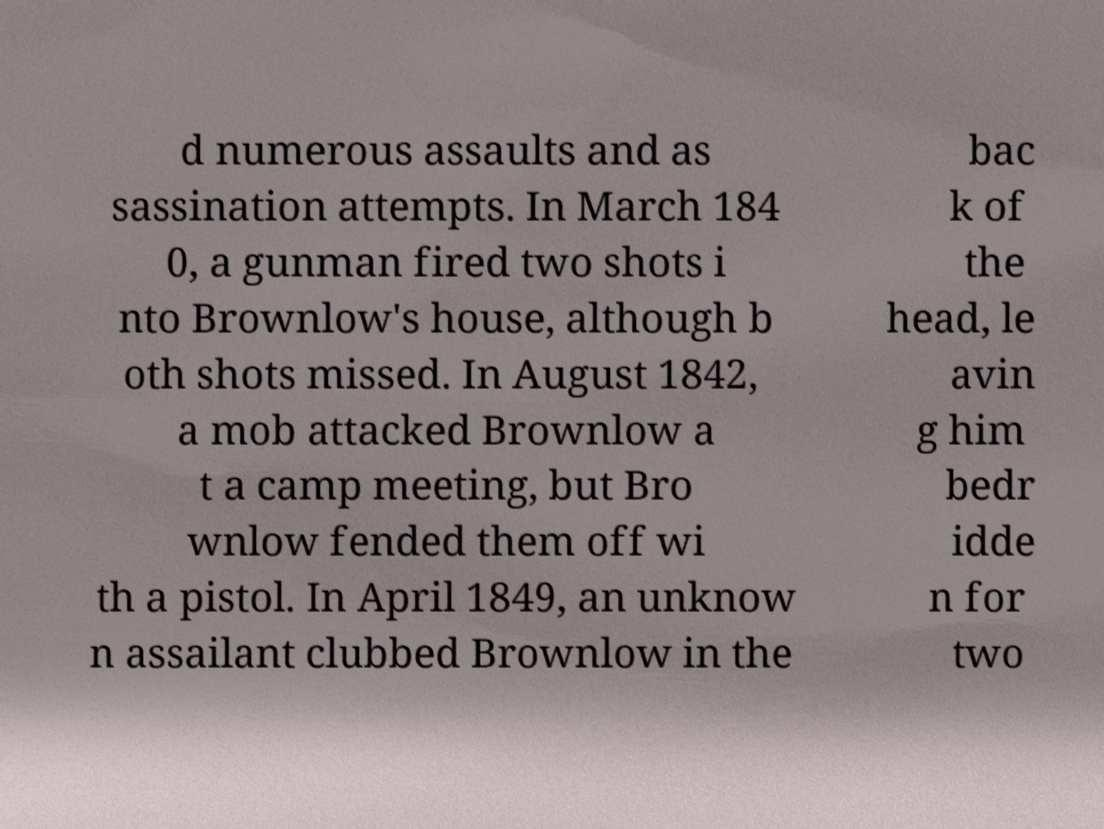Please read and relay the text visible in this image. What does it say? d numerous assaults and as sassination attempts. In March 184 0, a gunman fired two shots i nto Brownlow's house, although b oth shots missed. In August 1842, a mob attacked Brownlow a t a camp meeting, but Bro wnlow fended them off wi th a pistol. In April 1849, an unknow n assailant clubbed Brownlow in the bac k of the head, le avin g him bedr idde n for two 